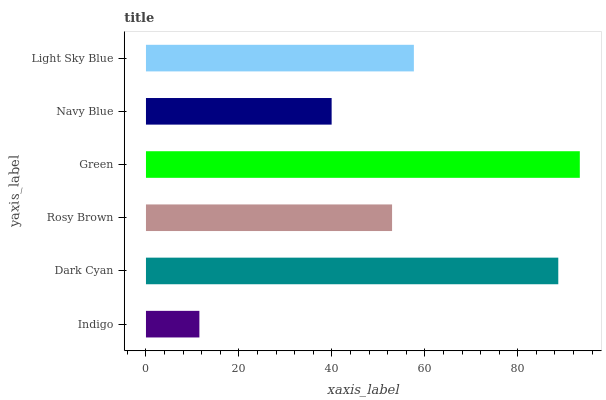Is Indigo the minimum?
Answer yes or no. Yes. Is Green the maximum?
Answer yes or no. Yes. Is Dark Cyan the minimum?
Answer yes or no. No. Is Dark Cyan the maximum?
Answer yes or no. No. Is Dark Cyan greater than Indigo?
Answer yes or no. Yes. Is Indigo less than Dark Cyan?
Answer yes or no. Yes. Is Indigo greater than Dark Cyan?
Answer yes or no. No. Is Dark Cyan less than Indigo?
Answer yes or no. No. Is Light Sky Blue the high median?
Answer yes or no. Yes. Is Rosy Brown the low median?
Answer yes or no. Yes. Is Green the high median?
Answer yes or no. No. Is Green the low median?
Answer yes or no. No. 